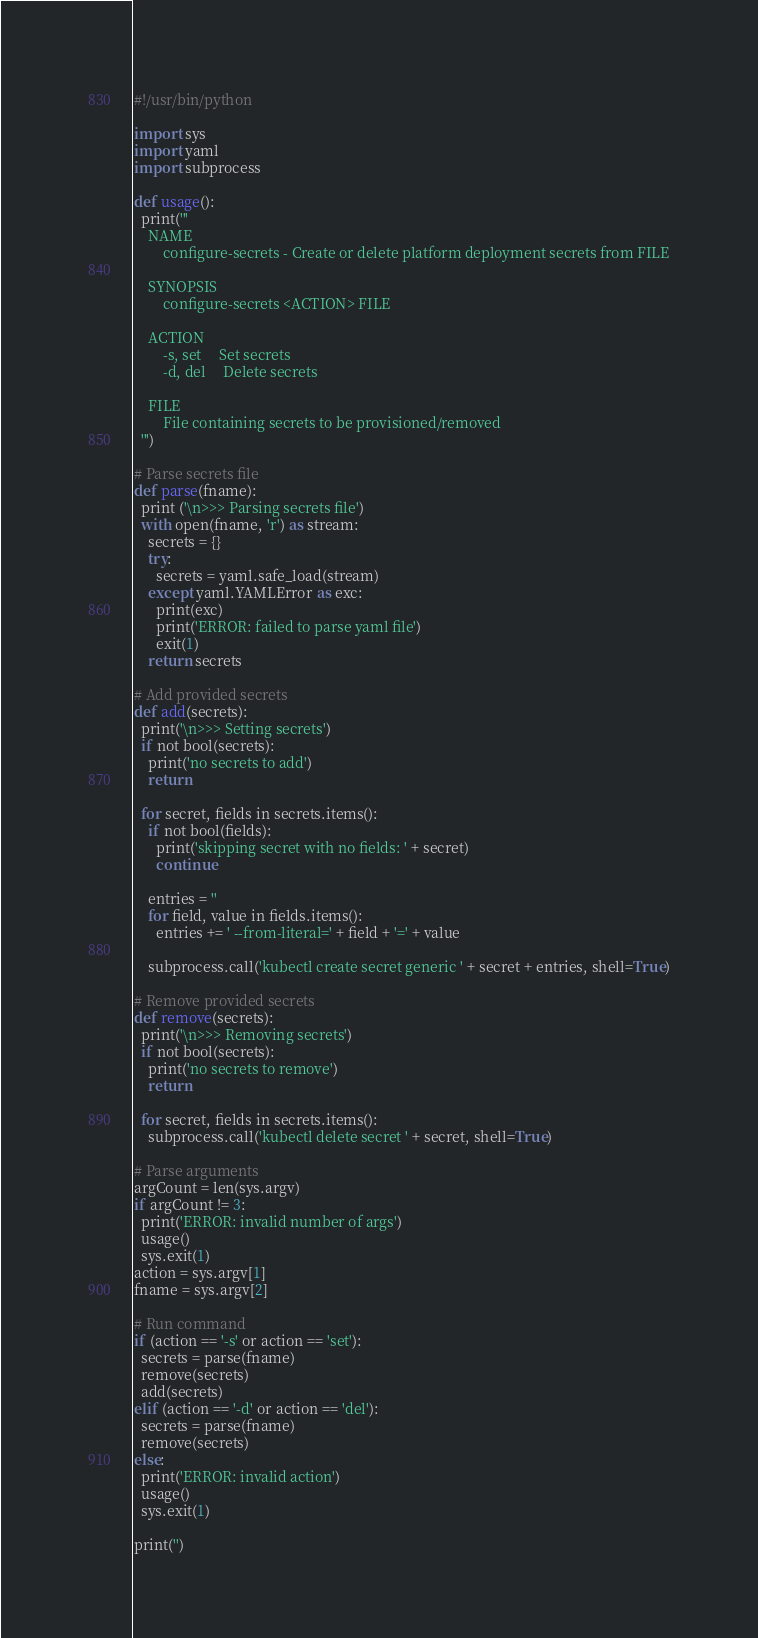<code> <loc_0><loc_0><loc_500><loc_500><_Python_>#!/usr/bin/python

import sys
import yaml
import subprocess

def usage():
  print('''
    NAME
        configure-secrets - Create or delete platform deployment secrets from FILE

    SYNOPSIS
        configure-secrets <ACTION> FILE

    ACTION
        -s, set     Set secrets
        -d, del     Delete secrets

    FILE
        File containing secrets to be provisioned/removed
  ''')

# Parse secrets file
def parse(fname):
  print ('\n>>> Parsing secrets file')
  with open(fname, 'r') as stream:
    secrets = {}
    try:
      secrets = yaml.safe_load(stream)
    except yaml.YAMLError as exc:
      print(exc)
      print('ERROR: failed to parse yaml file')
      exit(1)
    return secrets

# Add provided secrets 
def add(secrets):
  print('\n>>> Setting secrets')
  if not bool(secrets):
    print('no secrets to add')
    return

  for secret, fields in secrets.items():
    if not bool(fields):
      print('skipping secret with no fields: ' + secret)
      continue

    entries = ''
    for field, value in fields.items():
      entries += ' --from-literal=' + field + '=' + value

    subprocess.call('kubectl create secret generic ' + secret + entries, shell=True)

# Remove provided secrets
def remove(secrets):
  print('\n>>> Removing secrets')
  if not bool(secrets):
    print('no secrets to remove')
    return

  for secret, fields in secrets.items():
    subprocess.call('kubectl delete secret ' + secret, shell=True)

# Parse arguments
argCount = len(sys.argv)
if argCount != 3:
  print('ERROR: invalid number of args')
  usage()
  sys.exit(1)
action = sys.argv[1]
fname = sys.argv[2]

# Run command
if (action == '-s' or action == 'set'):
  secrets = parse(fname)
  remove(secrets)
  add(secrets)
elif (action == '-d' or action == 'del'):
  secrets = parse(fname)
  remove(secrets)
else:
  print('ERROR: invalid action')
  usage()
  sys.exit(1)

print('')


</code> 